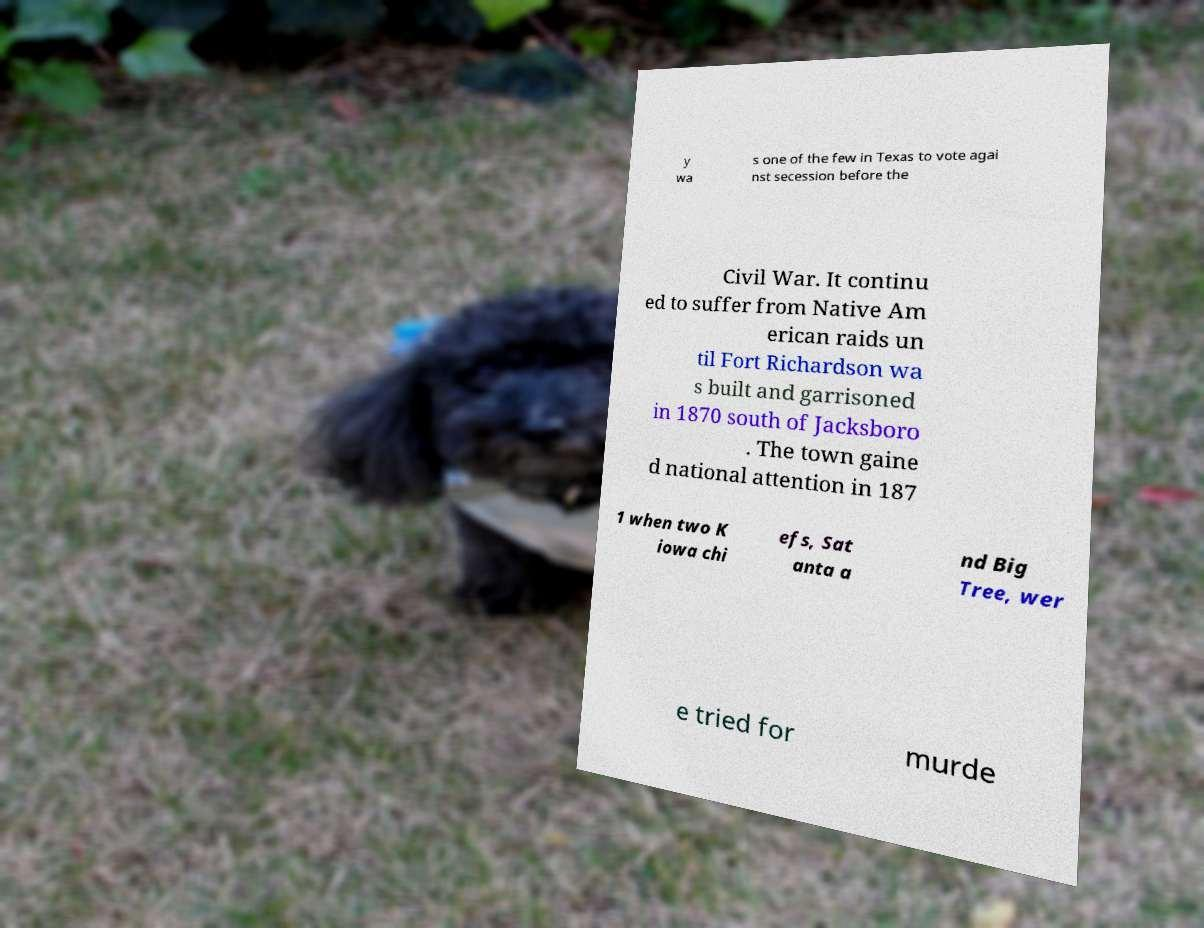Could you assist in decoding the text presented in this image and type it out clearly? y wa s one of the few in Texas to vote agai nst secession before the Civil War. It continu ed to suffer from Native Am erican raids un til Fort Richardson wa s built and garrisoned in 1870 south of Jacksboro . The town gaine d national attention in 187 1 when two K iowa chi efs, Sat anta a nd Big Tree, wer e tried for murde 